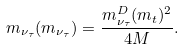Convert formula to latex. <formula><loc_0><loc_0><loc_500><loc_500>m _ { \nu _ { \tau } } ( m _ { \nu _ { \tau } } ) = \frac { { m ^ { D } _ { \nu _ { \tau } } } ( m _ { t } ) ^ { 2 } } { 4 M } .</formula> 